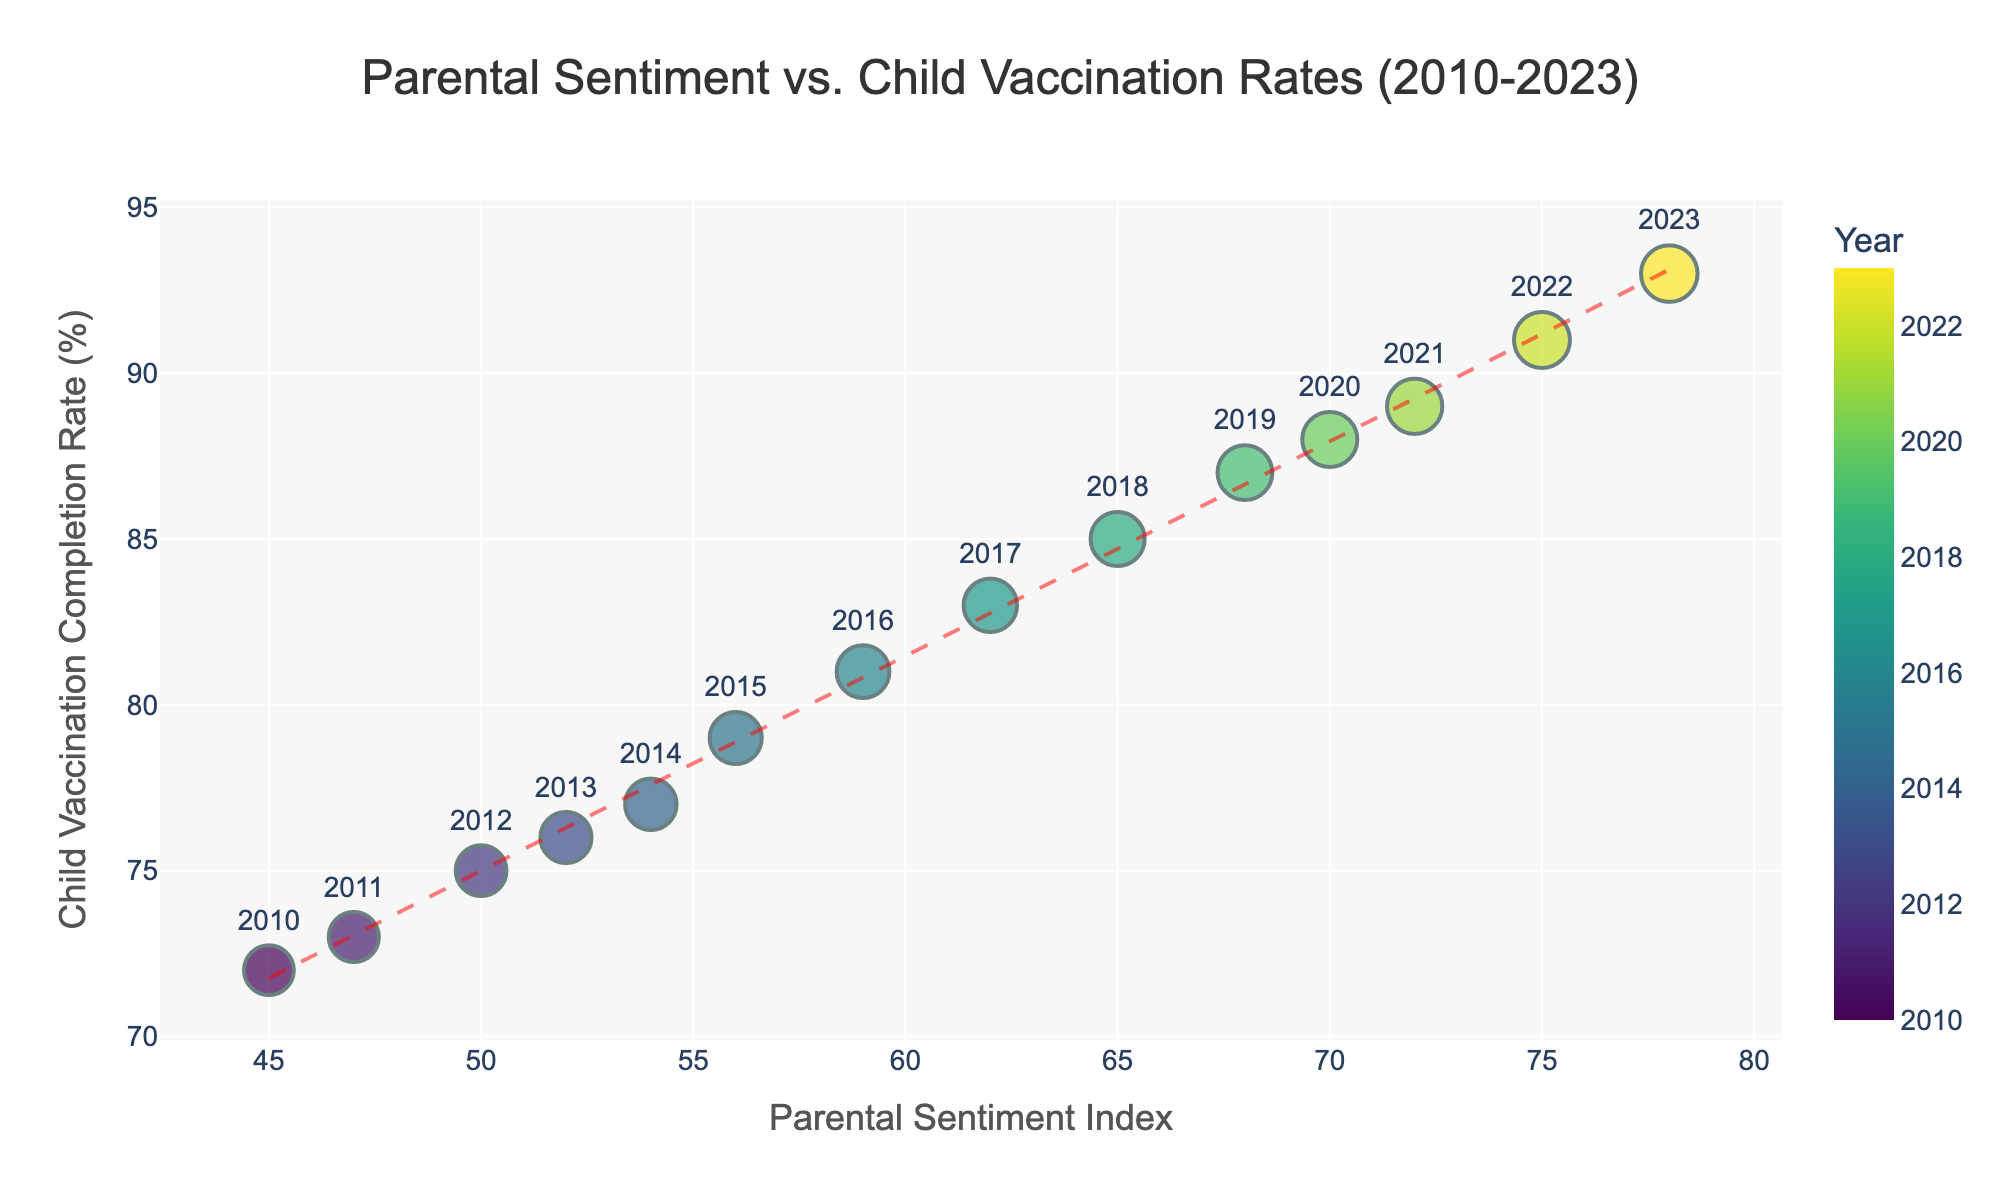How many years are displayed in the figure? There are data points for each year, and the x-axis labels list the years. We can count them to find the total number of years.
Answer: 14 What's the highest Child Vaccination Completion Rate recorded? Look at the y-axis and find the highest point on the scatter plot. The point corresponding to 2023 shows the maximum child vaccination completion rate.
Answer: 93% By how many points did the Parental Sentiment Index increase from 2010 to 2023? Subtract the Parental Sentiment Index of 2010 from that of 2023. The indices are 45 and 78 respectively.
Answer: 33 points What is the trend in the relationship between Parental Sentiment Index and Child Vaccination Completion Rate over time? Look at the trend line added to the scatter plot. The line has a positive slope, indicating that as the Parental Sentiment Index increases, the Child Vaccination Completion Rate also increases.
Answer: Positive trend In which year did the Child Vaccination Completion Rate reach 85%? Find the data point where the Child Vaccination Completion Rate is 85% and identify the corresponding year. It is labeled with the year 2018.
Answer: 2018 Which two consecutive years saw the largest increase in Child Vaccination Completion Rate? Calculate the differences in the Child Vaccination Completion Rate between consecutive years. The largest difference is between 2017 and 2018.
Answer: 2017-2018 What is the average Parental Sentiment Index over the years shown? Add up all the Parental Sentiment Index values and divide by the number of years (14). The sum is 913, so the average is 913/14.
Answer: 65.2 How does the trend line help interpret the scatter plot? The trend line helps to identify the overall direction of the relationship between the Parental Sentiment Index and the Child Vaccination Completion Rate. It makes it clearer that there is a positive correlation between the two variables.
Answer: Identifies positive correlation What can be inferred from the visual clustering of data points in the figure? The data points are clustered along the trend line, suggesting a strong correlation between the Parental Sentiment Index and the Child Vaccination Completion Rate. Few outliers indicate consistent yearly improvements.
Answer: Strong correlation 